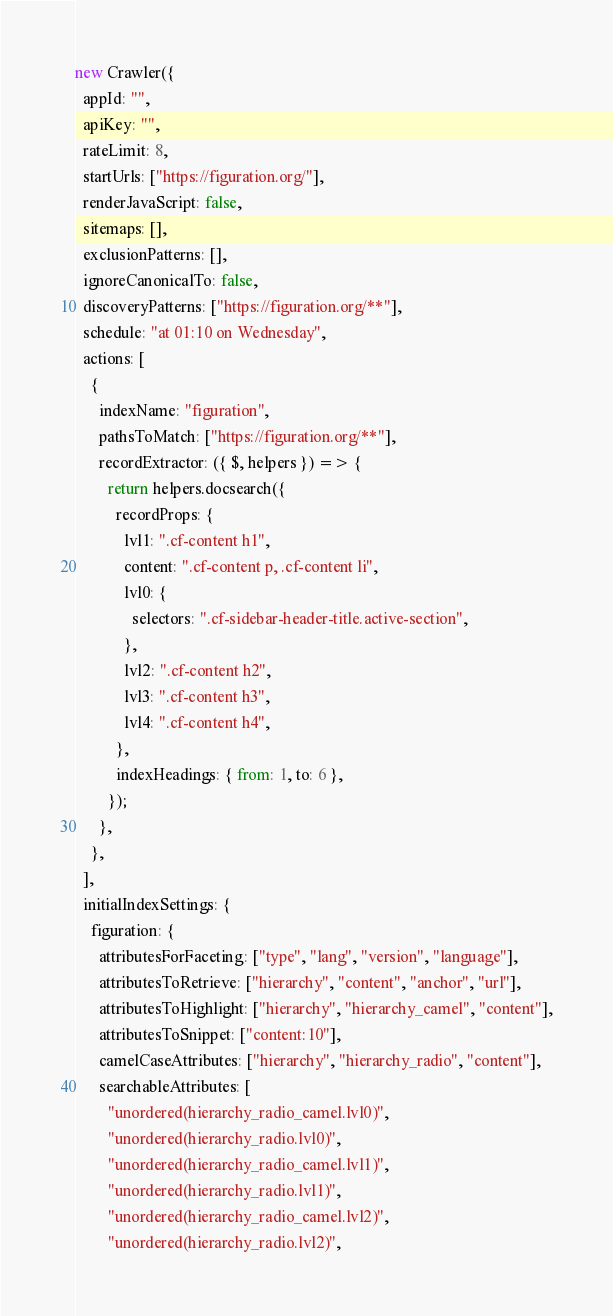Convert code to text. <code><loc_0><loc_0><loc_500><loc_500><_JavaScript_>new Crawler({
  appId: "",
  apiKey: "",
  rateLimit: 8,
  startUrls: ["https://figuration.org/"],
  renderJavaScript: false,
  sitemaps: [],
  exclusionPatterns: [],
  ignoreCanonicalTo: false,
  discoveryPatterns: ["https://figuration.org/**"],
  schedule: "at 01:10 on Wednesday",
  actions: [
    {
      indexName: "figuration",
      pathsToMatch: ["https://figuration.org/**"],
      recordExtractor: ({ $, helpers }) => {
        return helpers.docsearch({
          recordProps: {
            lvl1: ".cf-content h1",
            content: ".cf-content p, .cf-content li",
            lvl0: {
              selectors: ".cf-sidebar-header-title.active-section",
            },
            lvl2: ".cf-content h2",
            lvl3: ".cf-content h3",
            lvl4: ".cf-content h4",
          },
          indexHeadings: { from: 1, to: 6 },
        });
      },
    },
  ],
  initialIndexSettings: {
    figuration: {
      attributesForFaceting: ["type", "lang", "version", "language"],
      attributesToRetrieve: ["hierarchy", "content", "anchor", "url"],
      attributesToHighlight: ["hierarchy", "hierarchy_camel", "content"],
      attributesToSnippet: ["content:10"],
      camelCaseAttributes: ["hierarchy", "hierarchy_radio", "content"],
      searchableAttributes: [
        "unordered(hierarchy_radio_camel.lvl0)",
        "unordered(hierarchy_radio.lvl0)",
        "unordered(hierarchy_radio_camel.lvl1)",
        "unordered(hierarchy_radio.lvl1)",
        "unordered(hierarchy_radio_camel.lvl2)",
        "unordered(hierarchy_radio.lvl2)",</code> 